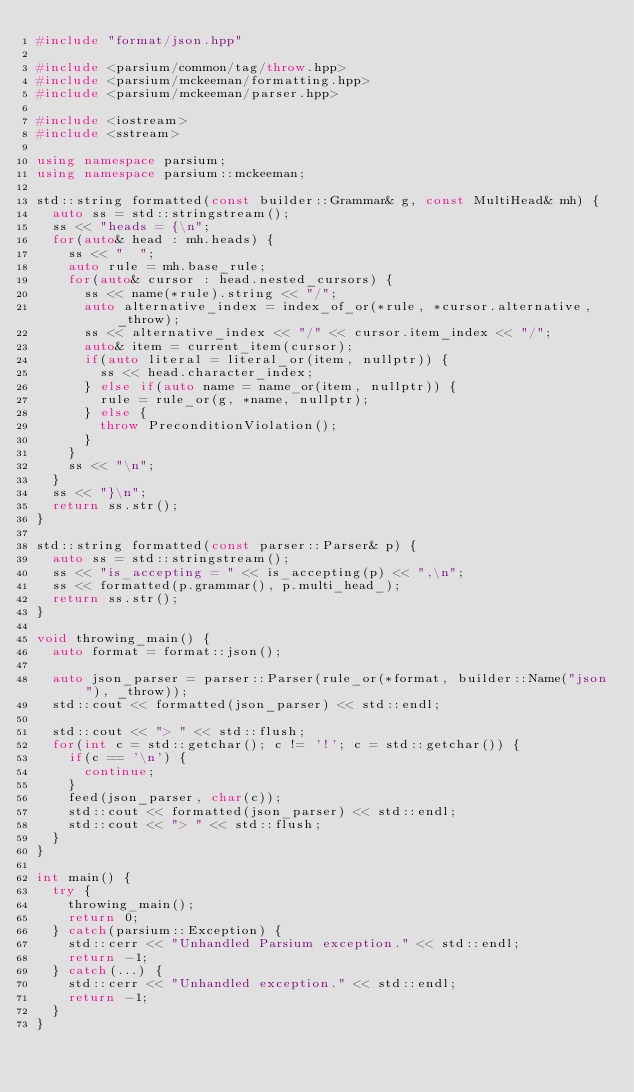Convert code to text. <code><loc_0><loc_0><loc_500><loc_500><_C++_>#include "format/json.hpp"

#include <parsium/common/tag/throw.hpp>
#include <parsium/mckeeman/formatting.hpp>
#include <parsium/mckeeman/parser.hpp>

#include <iostream>
#include <sstream>

using namespace parsium;
using namespace parsium::mckeeman;

std::string formatted(const builder::Grammar& g, const MultiHead& mh) {
	auto ss = std::stringstream();
	ss << "heads = {\n";
	for(auto& head : mh.heads) {
		ss << "  ";
		auto rule = mh.base_rule;
		for(auto& cursor : head.nested_cursors) {
			ss << name(*rule).string << "/";
			auto alternative_index = index_of_or(*rule, *cursor.alternative, _throw);
			ss << alternative_index << "/" << cursor.item_index << "/";
			auto& item = current_item(cursor);
			if(auto literal = literal_or(item, nullptr)) {
				ss << head.character_index;
			} else if(auto name = name_or(item, nullptr)) {
				rule = rule_or(g, *name, nullptr);
			} else {
				throw PreconditionViolation();
			}
		}
		ss << "\n";
	}
	ss << "}\n";
	return ss.str();
}

std::string formatted(const parser::Parser& p) {
	auto ss = std::stringstream();
	ss << "is_accepting = " << is_accepting(p) << ",\n";
	ss << formatted(p.grammar(), p.multi_head_);
	return ss.str();
}

void throwing_main() {
	auto format = format::json();

	auto json_parser = parser::Parser(rule_or(*format, builder::Name("json"), _throw));
	std::cout << formatted(json_parser) << std::endl;

	std::cout << "> " << std::flush;
	for(int c = std::getchar(); c != '!'; c = std::getchar()) {
		if(c == '\n') {
			continue;
		}
		feed(json_parser, char(c));
		std::cout << formatted(json_parser) << std::endl;
		std::cout << "> " << std::flush;
	}
}

int main() {
	try {
		throwing_main();
		return 0;
	} catch(parsium::Exception) {
		std::cerr << "Unhandled Parsium exception." << std::endl;
		return -1;
	} catch(...) {
		std::cerr << "Unhandled exception." << std::endl;
		return -1;
	}
}
</code> 